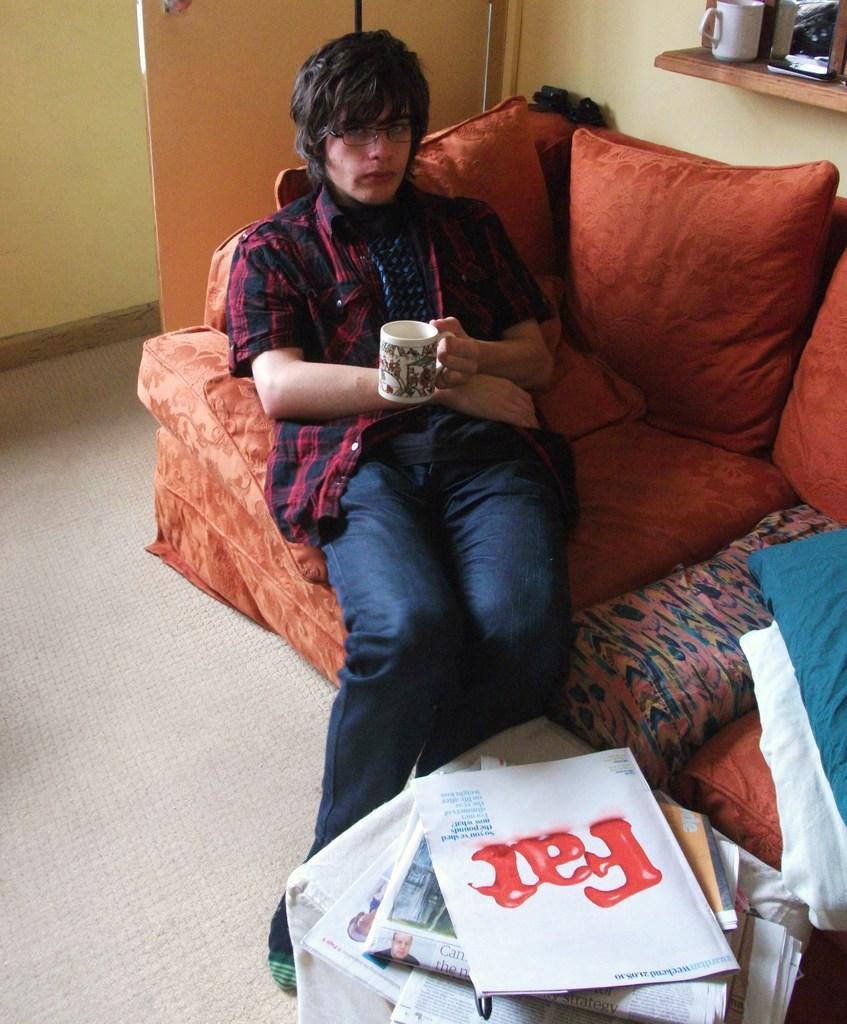Can you describe this image briefly? In the foreground of the picture there is a table, on the table there are newspapers. In the center of the picture there is a couch, on the couch there are pillows and a person sitting. At the top there are cup, mirror, door and wall. 